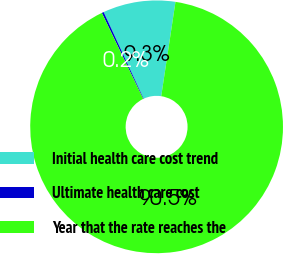Convert chart to OTSL. <chart><loc_0><loc_0><loc_500><loc_500><pie_chart><fcel>Initial health care cost trend<fcel>Ultimate health care cost<fcel>Year that the rate reaches the<nl><fcel>9.27%<fcel>0.25%<fcel>90.48%<nl></chart> 